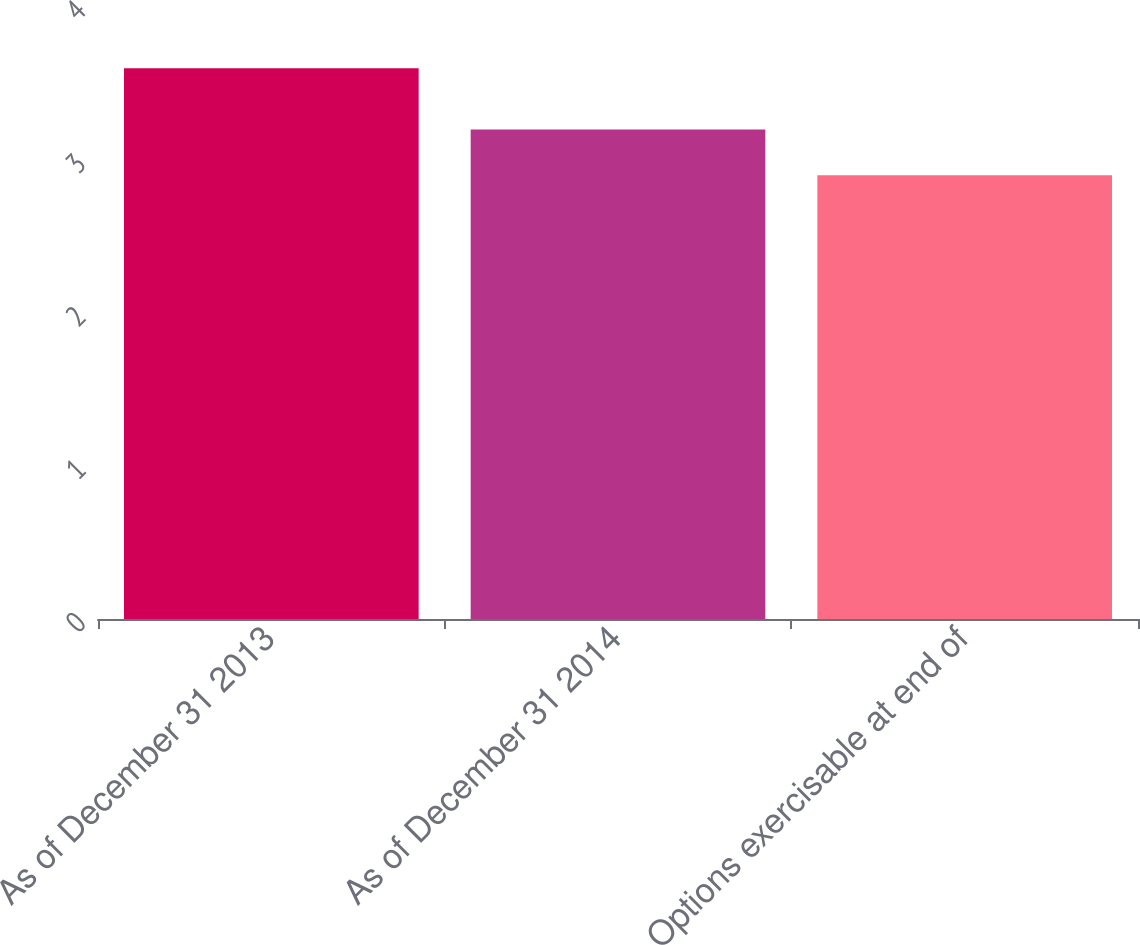Convert chart. <chart><loc_0><loc_0><loc_500><loc_500><bar_chart><fcel>As of December 31 2013<fcel>As of December 31 2014<fcel>Options exercisable at end of<nl><fcel>3.6<fcel>3.2<fcel>2.9<nl></chart> 